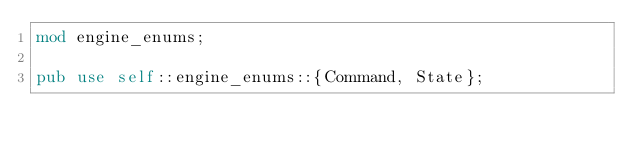<code> <loc_0><loc_0><loc_500><loc_500><_Rust_>mod engine_enums;

pub use self::engine_enums::{Command, State};
</code> 